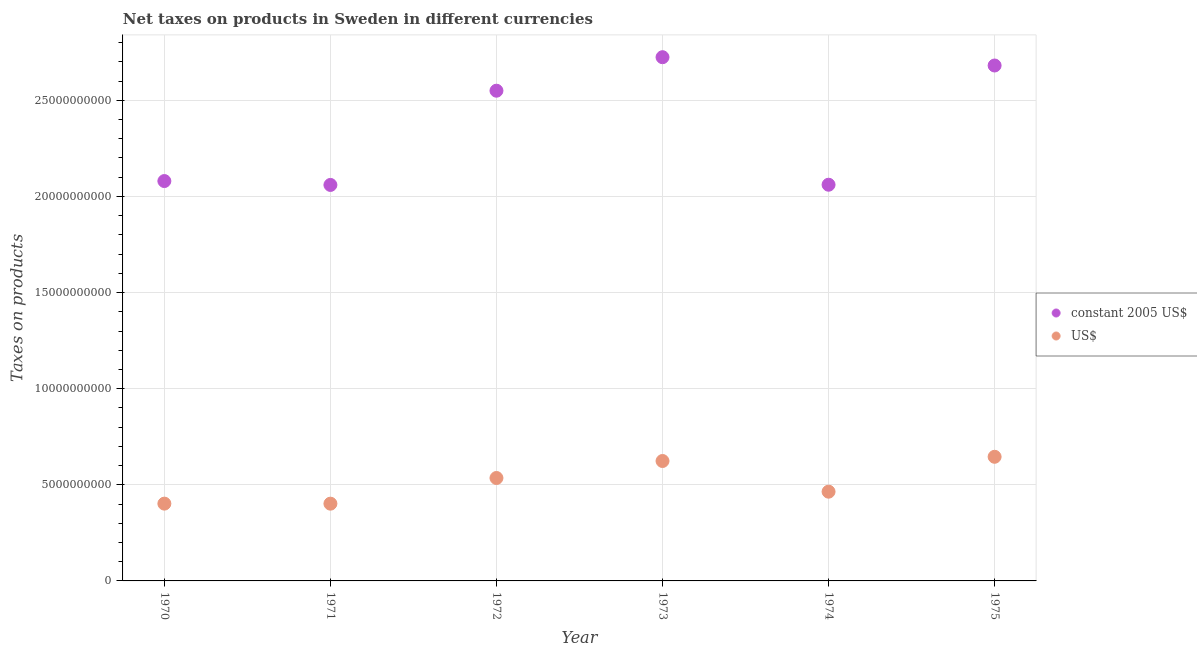How many different coloured dotlines are there?
Offer a terse response. 2. Is the number of dotlines equal to the number of legend labels?
Provide a succinct answer. Yes. What is the net taxes in constant 2005 us$ in 1973?
Ensure brevity in your answer.  2.72e+1. Across all years, what is the maximum net taxes in constant 2005 us$?
Make the answer very short. 2.72e+1. Across all years, what is the minimum net taxes in us$?
Offer a terse response. 4.02e+09. In which year was the net taxes in constant 2005 us$ maximum?
Offer a terse response. 1973. In which year was the net taxes in us$ minimum?
Ensure brevity in your answer.  1971. What is the total net taxes in constant 2005 us$ in the graph?
Keep it short and to the point. 1.42e+11. What is the difference between the net taxes in us$ in 1971 and that in 1973?
Give a very brief answer. -2.22e+09. What is the difference between the net taxes in constant 2005 us$ in 1972 and the net taxes in us$ in 1974?
Provide a succinct answer. 2.09e+1. What is the average net taxes in constant 2005 us$ per year?
Your answer should be compact. 2.36e+1. In the year 1973, what is the difference between the net taxes in constant 2005 us$ and net taxes in us$?
Give a very brief answer. 2.10e+1. What is the ratio of the net taxes in us$ in 1971 to that in 1972?
Your answer should be very brief. 0.75. Is the net taxes in us$ in 1971 less than that in 1974?
Make the answer very short. Yes. Is the difference between the net taxes in us$ in 1970 and 1972 greater than the difference between the net taxes in constant 2005 us$ in 1970 and 1972?
Offer a very short reply. Yes. What is the difference between the highest and the second highest net taxes in constant 2005 us$?
Your answer should be compact. 4.32e+08. What is the difference between the highest and the lowest net taxes in constant 2005 us$?
Your answer should be compact. 6.64e+09. Does the net taxes in constant 2005 us$ monotonically increase over the years?
Your response must be concise. No. Is the net taxes in constant 2005 us$ strictly greater than the net taxes in us$ over the years?
Your answer should be very brief. Yes. What is the difference between two consecutive major ticks on the Y-axis?
Provide a short and direct response. 5.00e+09. Are the values on the major ticks of Y-axis written in scientific E-notation?
Your answer should be compact. No. Does the graph contain any zero values?
Keep it short and to the point. No. Does the graph contain grids?
Ensure brevity in your answer.  Yes. What is the title of the graph?
Keep it short and to the point. Net taxes on products in Sweden in different currencies. Does "Imports" appear as one of the legend labels in the graph?
Give a very brief answer. No. What is the label or title of the Y-axis?
Provide a succinct answer. Taxes on products. What is the Taxes on products in constant 2005 US$ in 1970?
Your response must be concise. 2.08e+1. What is the Taxes on products of US$ in 1970?
Your answer should be compact. 4.02e+09. What is the Taxes on products of constant 2005 US$ in 1971?
Your response must be concise. 2.06e+1. What is the Taxes on products in US$ in 1971?
Keep it short and to the point. 4.02e+09. What is the Taxes on products in constant 2005 US$ in 1972?
Provide a succinct answer. 2.55e+1. What is the Taxes on products in US$ in 1972?
Make the answer very short. 5.35e+09. What is the Taxes on products of constant 2005 US$ in 1973?
Keep it short and to the point. 2.72e+1. What is the Taxes on products in US$ in 1973?
Your response must be concise. 6.24e+09. What is the Taxes on products of constant 2005 US$ in 1974?
Offer a very short reply. 2.06e+1. What is the Taxes on products in US$ in 1974?
Make the answer very short. 4.64e+09. What is the Taxes on products in constant 2005 US$ in 1975?
Provide a succinct answer. 2.68e+1. What is the Taxes on products of US$ in 1975?
Your response must be concise. 6.46e+09. Across all years, what is the maximum Taxes on products of constant 2005 US$?
Provide a short and direct response. 2.72e+1. Across all years, what is the maximum Taxes on products in US$?
Your answer should be compact. 6.46e+09. Across all years, what is the minimum Taxes on products in constant 2005 US$?
Your answer should be compact. 2.06e+1. Across all years, what is the minimum Taxes on products in US$?
Offer a terse response. 4.02e+09. What is the total Taxes on products of constant 2005 US$ in the graph?
Give a very brief answer. 1.42e+11. What is the total Taxes on products in US$ in the graph?
Provide a short and direct response. 3.07e+1. What is the difference between the Taxes on products in constant 2005 US$ in 1970 and that in 1971?
Your answer should be compact. 2.02e+08. What is the difference between the Taxes on products of US$ in 1970 and that in 1971?
Your answer should be very brief. 2.31e+06. What is the difference between the Taxes on products of constant 2005 US$ in 1970 and that in 1972?
Make the answer very short. -4.70e+09. What is the difference between the Taxes on products in US$ in 1970 and that in 1972?
Keep it short and to the point. -1.33e+09. What is the difference between the Taxes on products in constant 2005 US$ in 1970 and that in 1973?
Offer a very short reply. -6.44e+09. What is the difference between the Taxes on products of US$ in 1970 and that in 1973?
Give a very brief answer. -2.22e+09. What is the difference between the Taxes on products in constant 2005 US$ in 1970 and that in 1974?
Keep it short and to the point. 1.91e+08. What is the difference between the Taxes on products of US$ in 1970 and that in 1974?
Your answer should be compact. -6.22e+08. What is the difference between the Taxes on products of constant 2005 US$ in 1970 and that in 1975?
Give a very brief answer. -6.01e+09. What is the difference between the Taxes on products of US$ in 1970 and that in 1975?
Give a very brief answer. -2.44e+09. What is the difference between the Taxes on products of constant 2005 US$ in 1971 and that in 1972?
Your answer should be compact. -4.90e+09. What is the difference between the Taxes on products of US$ in 1971 and that in 1972?
Provide a short and direct response. -1.34e+09. What is the difference between the Taxes on products of constant 2005 US$ in 1971 and that in 1973?
Your response must be concise. -6.64e+09. What is the difference between the Taxes on products of US$ in 1971 and that in 1973?
Offer a terse response. -2.22e+09. What is the difference between the Taxes on products in constant 2005 US$ in 1971 and that in 1974?
Keep it short and to the point. -1.10e+07. What is the difference between the Taxes on products in US$ in 1971 and that in 1974?
Your response must be concise. -6.24e+08. What is the difference between the Taxes on products of constant 2005 US$ in 1971 and that in 1975?
Your answer should be very brief. -6.21e+09. What is the difference between the Taxes on products in US$ in 1971 and that in 1975?
Offer a terse response. -2.44e+09. What is the difference between the Taxes on products in constant 2005 US$ in 1972 and that in 1973?
Offer a terse response. -1.74e+09. What is the difference between the Taxes on products of US$ in 1972 and that in 1973?
Provide a short and direct response. -8.84e+08. What is the difference between the Taxes on products of constant 2005 US$ in 1972 and that in 1974?
Your response must be concise. 4.89e+09. What is the difference between the Taxes on products of US$ in 1972 and that in 1974?
Provide a short and direct response. 7.12e+08. What is the difference between the Taxes on products in constant 2005 US$ in 1972 and that in 1975?
Ensure brevity in your answer.  -1.31e+09. What is the difference between the Taxes on products in US$ in 1972 and that in 1975?
Your answer should be compact. -1.10e+09. What is the difference between the Taxes on products of constant 2005 US$ in 1973 and that in 1974?
Make the answer very short. 6.63e+09. What is the difference between the Taxes on products of US$ in 1973 and that in 1974?
Your answer should be very brief. 1.60e+09. What is the difference between the Taxes on products in constant 2005 US$ in 1973 and that in 1975?
Provide a succinct answer. 4.32e+08. What is the difference between the Taxes on products of US$ in 1973 and that in 1975?
Your answer should be very brief. -2.19e+08. What is the difference between the Taxes on products in constant 2005 US$ in 1974 and that in 1975?
Ensure brevity in your answer.  -6.20e+09. What is the difference between the Taxes on products of US$ in 1974 and that in 1975?
Ensure brevity in your answer.  -1.81e+09. What is the difference between the Taxes on products in constant 2005 US$ in 1970 and the Taxes on products in US$ in 1971?
Give a very brief answer. 1.68e+1. What is the difference between the Taxes on products in constant 2005 US$ in 1970 and the Taxes on products in US$ in 1972?
Give a very brief answer. 1.54e+1. What is the difference between the Taxes on products of constant 2005 US$ in 1970 and the Taxes on products of US$ in 1973?
Your answer should be very brief. 1.46e+1. What is the difference between the Taxes on products of constant 2005 US$ in 1970 and the Taxes on products of US$ in 1974?
Make the answer very short. 1.62e+1. What is the difference between the Taxes on products in constant 2005 US$ in 1970 and the Taxes on products in US$ in 1975?
Your response must be concise. 1.43e+1. What is the difference between the Taxes on products of constant 2005 US$ in 1971 and the Taxes on products of US$ in 1972?
Ensure brevity in your answer.  1.52e+1. What is the difference between the Taxes on products in constant 2005 US$ in 1971 and the Taxes on products in US$ in 1973?
Offer a terse response. 1.44e+1. What is the difference between the Taxes on products in constant 2005 US$ in 1971 and the Taxes on products in US$ in 1974?
Offer a very short reply. 1.60e+1. What is the difference between the Taxes on products of constant 2005 US$ in 1971 and the Taxes on products of US$ in 1975?
Provide a short and direct response. 1.41e+1. What is the difference between the Taxes on products in constant 2005 US$ in 1972 and the Taxes on products in US$ in 1973?
Offer a terse response. 1.93e+1. What is the difference between the Taxes on products in constant 2005 US$ in 1972 and the Taxes on products in US$ in 1974?
Ensure brevity in your answer.  2.09e+1. What is the difference between the Taxes on products of constant 2005 US$ in 1972 and the Taxes on products of US$ in 1975?
Offer a very short reply. 1.90e+1. What is the difference between the Taxes on products of constant 2005 US$ in 1973 and the Taxes on products of US$ in 1974?
Offer a terse response. 2.26e+1. What is the difference between the Taxes on products in constant 2005 US$ in 1973 and the Taxes on products in US$ in 1975?
Make the answer very short. 2.08e+1. What is the difference between the Taxes on products in constant 2005 US$ in 1974 and the Taxes on products in US$ in 1975?
Your answer should be compact. 1.42e+1. What is the average Taxes on products in constant 2005 US$ per year?
Make the answer very short. 2.36e+1. What is the average Taxes on products in US$ per year?
Give a very brief answer. 5.12e+09. In the year 1970, what is the difference between the Taxes on products of constant 2005 US$ and Taxes on products of US$?
Your response must be concise. 1.68e+1. In the year 1971, what is the difference between the Taxes on products of constant 2005 US$ and Taxes on products of US$?
Your answer should be compact. 1.66e+1. In the year 1972, what is the difference between the Taxes on products in constant 2005 US$ and Taxes on products in US$?
Make the answer very short. 2.01e+1. In the year 1973, what is the difference between the Taxes on products in constant 2005 US$ and Taxes on products in US$?
Offer a terse response. 2.10e+1. In the year 1974, what is the difference between the Taxes on products of constant 2005 US$ and Taxes on products of US$?
Provide a short and direct response. 1.60e+1. In the year 1975, what is the difference between the Taxes on products of constant 2005 US$ and Taxes on products of US$?
Offer a terse response. 2.04e+1. What is the ratio of the Taxes on products in constant 2005 US$ in 1970 to that in 1971?
Offer a very short reply. 1.01. What is the ratio of the Taxes on products in constant 2005 US$ in 1970 to that in 1972?
Give a very brief answer. 0.82. What is the ratio of the Taxes on products of US$ in 1970 to that in 1972?
Ensure brevity in your answer.  0.75. What is the ratio of the Taxes on products in constant 2005 US$ in 1970 to that in 1973?
Offer a terse response. 0.76. What is the ratio of the Taxes on products of US$ in 1970 to that in 1973?
Make the answer very short. 0.64. What is the ratio of the Taxes on products of constant 2005 US$ in 1970 to that in 1974?
Give a very brief answer. 1.01. What is the ratio of the Taxes on products in US$ in 1970 to that in 1974?
Give a very brief answer. 0.87. What is the ratio of the Taxes on products in constant 2005 US$ in 1970 to that in 1975?
Your response must be concise. 0.78. What is the ratio of the Taxes on products of US$ in 1970 to that in 1975?
Give a very brief answer. 0.62. What is the ratio of the Taxes on products in constant 2005 US$ in 1971 to that in 1972?
Provide a succinct answer. 0.81. What is the ratio of the Taxes on products of US$ in 1971 to that in 1972?
Give a very brief answer. 0.75. What is the ratio of the Taxes on products of constant 2005 US$ in 1971 to that in 1973?
Your response must be concise. 0.76. What is the ratio of the Taxes on products in US$ in 1971 to that in 1973?
Keep it short and to the point. 0.64. What is the ratio of the Taxes on products of US$ in 1971 to that in 1974?
Provide a short and direct response. 0.87. What is the ratio of the Taxes on products in constant 2005 US$ in 1971 to that in 1975?
Give a very brief answer. 0.77. What is the ratio of the Taxes on products in US$ in 1971 to that in 1975?
Provide a succinct answer. 0.62. What is the ratio of the Taxes on products of constant 2005 US$ in 1972 to that in 1973?
Your answer should be compact. 0.94. What is the ratio of the Taxes on products in US$ in 1972 to that in 1973?
Your response must be concise. 0.86. What is the ratio of the Taxes on products in constant 2005 US$ in 1972 to that in 1974?
Provide a short and direct response. 1.24. What is the ratio of the Taxes on products of US$ in 1972 to that in 1974?
Provide a short and direct response. 1.15. What is the ratio of the Taxes on products in constant 2005 US$ in 1972 to that in 1975?
Your response must be concise. 0.95. What is the ratio of the Taxes on products of US$ in 1972 to that in 1975?
Provide a succinct answer. 0.83. What is the ratio of the Taxes on products of constant 2005 US$ in 1973 to that in 1974?
Provide a short and direct response. 1.32. What is the ratio of the Taxes on products of US$ in 1973 to that in 1974?
Your answer should be very brief. 1.34. What is the ratio of the Taxes on products of constant 2005 US$ in 1973 to that in 1975?
Ensure brevity in your answer.  1.02. What is the ratio of the Taxes on products of US$ in 1973 to that in 1975?
Provide a short and direct response. 0.97. What is the ratio of the Taxes on products of constant 2005 US$ in 1974 to that in 1975?
Ensure brevity in your answer.  0.77. What is the ratio of the Taxes on products in US$ in 1974 to that in 1975?
Your answer should be compact. 0.72. What is the difference between the highest and the second highest Taxes on products in constant 2005 US$?
Your answer should be compact. 4.32e+08. What is the difference between the highest and the second highest Taxes on products in US$?
Make the answer very short. 2.19e+08. What is the difference between the highest and the lowest Taxes on products in constant 2005 US$?
Give a very brief answer. 6.64e+09. What is the difference between the highest and the lowest Taxes on products of US$?
Your response must be concise. 2.44e+09. 